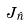<formula> <loc_0><loc_0><loc_500><loc_500>J _ { \hat { n } }</formula> 